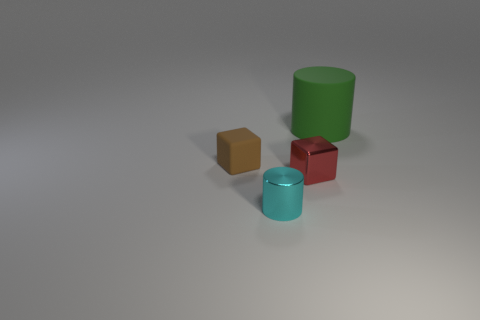Add 3 big matte things. How many objects exist? 7 Subtract all small red blocks. Subtract all blue objects. How many objects are left? 3 Add 4 cyan things. How many cyan things are left? 5 Add 1 red metal things. How many red metal things exist? 2 Subtract 0 purple balls. How many objects are left? 4 